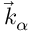Convert formula to latex. <formula><loc_0><loc_0><loc_500><loc_500>\vec { k } _ { \alpha }</formula> 